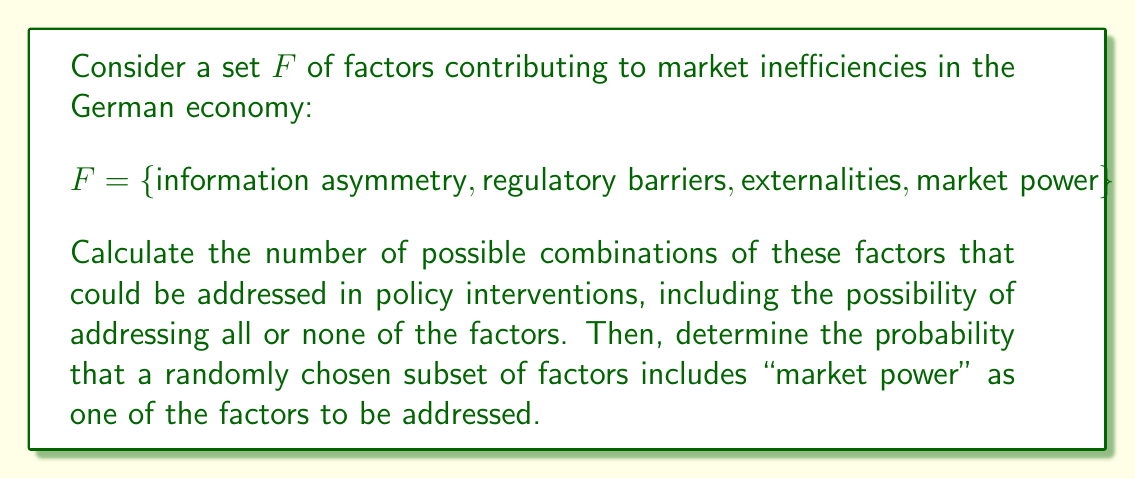Give your solution to this math problem. To solve this problem, we need to use the concept of power sets and probability theory.

1. First, let's calculate the number of possible combinations:
   The power set of a set $F$ with $n$ elements contains $2^n$ subsets.
   In this case, $|F| = 4$, so the number of subsets is $2^4 = 16$.

2. Now, let's list all the subsets to help us count those containing "market power":
   $\{\}$
   $\{\text{information asymmetry}\}$
   $\{\text{regulatory barriers}\}$
   $\{\text{externalities}\}$
   $\{\text{market power}\}$
   $\{\text{information asymmetry}, \text{regulatory barriers}\}$
   $\{\text{information asymmetry}, \text{externalities}\}$
   $\{\text{information asymmetry}, \text{market power}\}$
   $\{\text{regulatory barriers}, \text{externalities}\}$
   $\{\text{regulatory barriers}, \text{market power}\}$
   $\{\text{externalities}, \text{market power}\}$
   $\{\text{information asymmetry}, \text{regulatory barriers}, \text{externalities}\}$
   $\{\text{information asymmetry}, \text{regulatory barriers}, \text{market power}\}$
   $\{\text{information asymmetry}, \text{externalities}, \text{market power}\}$
   $\{\text{regulatory barriers}, \text{externalities}, \text{market power}\}$
   $\{\text{information asymmetry}, \text{regulatory barriers}, \text{externalities}, \text{market power}\}$

3. Count the subsets containing "market power":
   There are 8 subsets that include "market power".

4. Calculate the probability:
   Probability = (Number of favorable outcomes) / (Total number of possible outcomes)
   $P(\text{market power}) = \frac{8}{16} = \frac{1}{2} = 0.5$

This means that there is a 50% chance that a randomly chosen subset of factors includes "market power" as one of the factors to be addressed.
Answer: The number of possible combinations is 16, and the probability that a randomly chosen subset includes "market power" is 0.5 or 50%. 